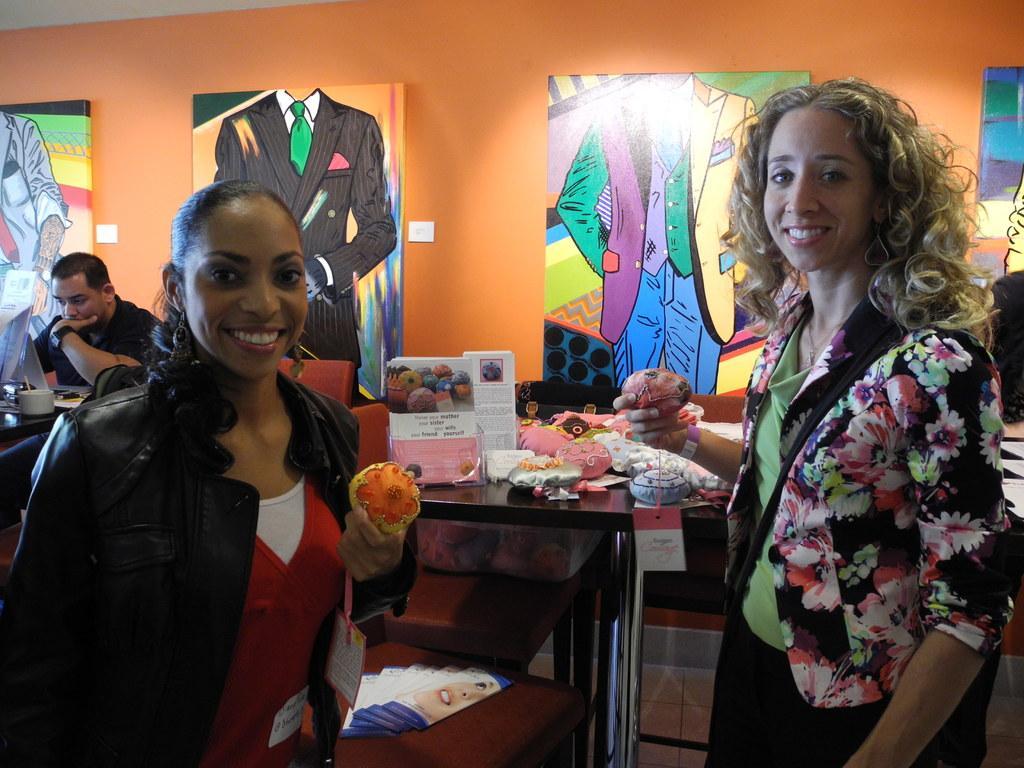Describe this image in one or two sentences. In this image, there are two persons wearing clothes and holding something with their hands. There is a table in the middle of the image. There are boards on the wall. 